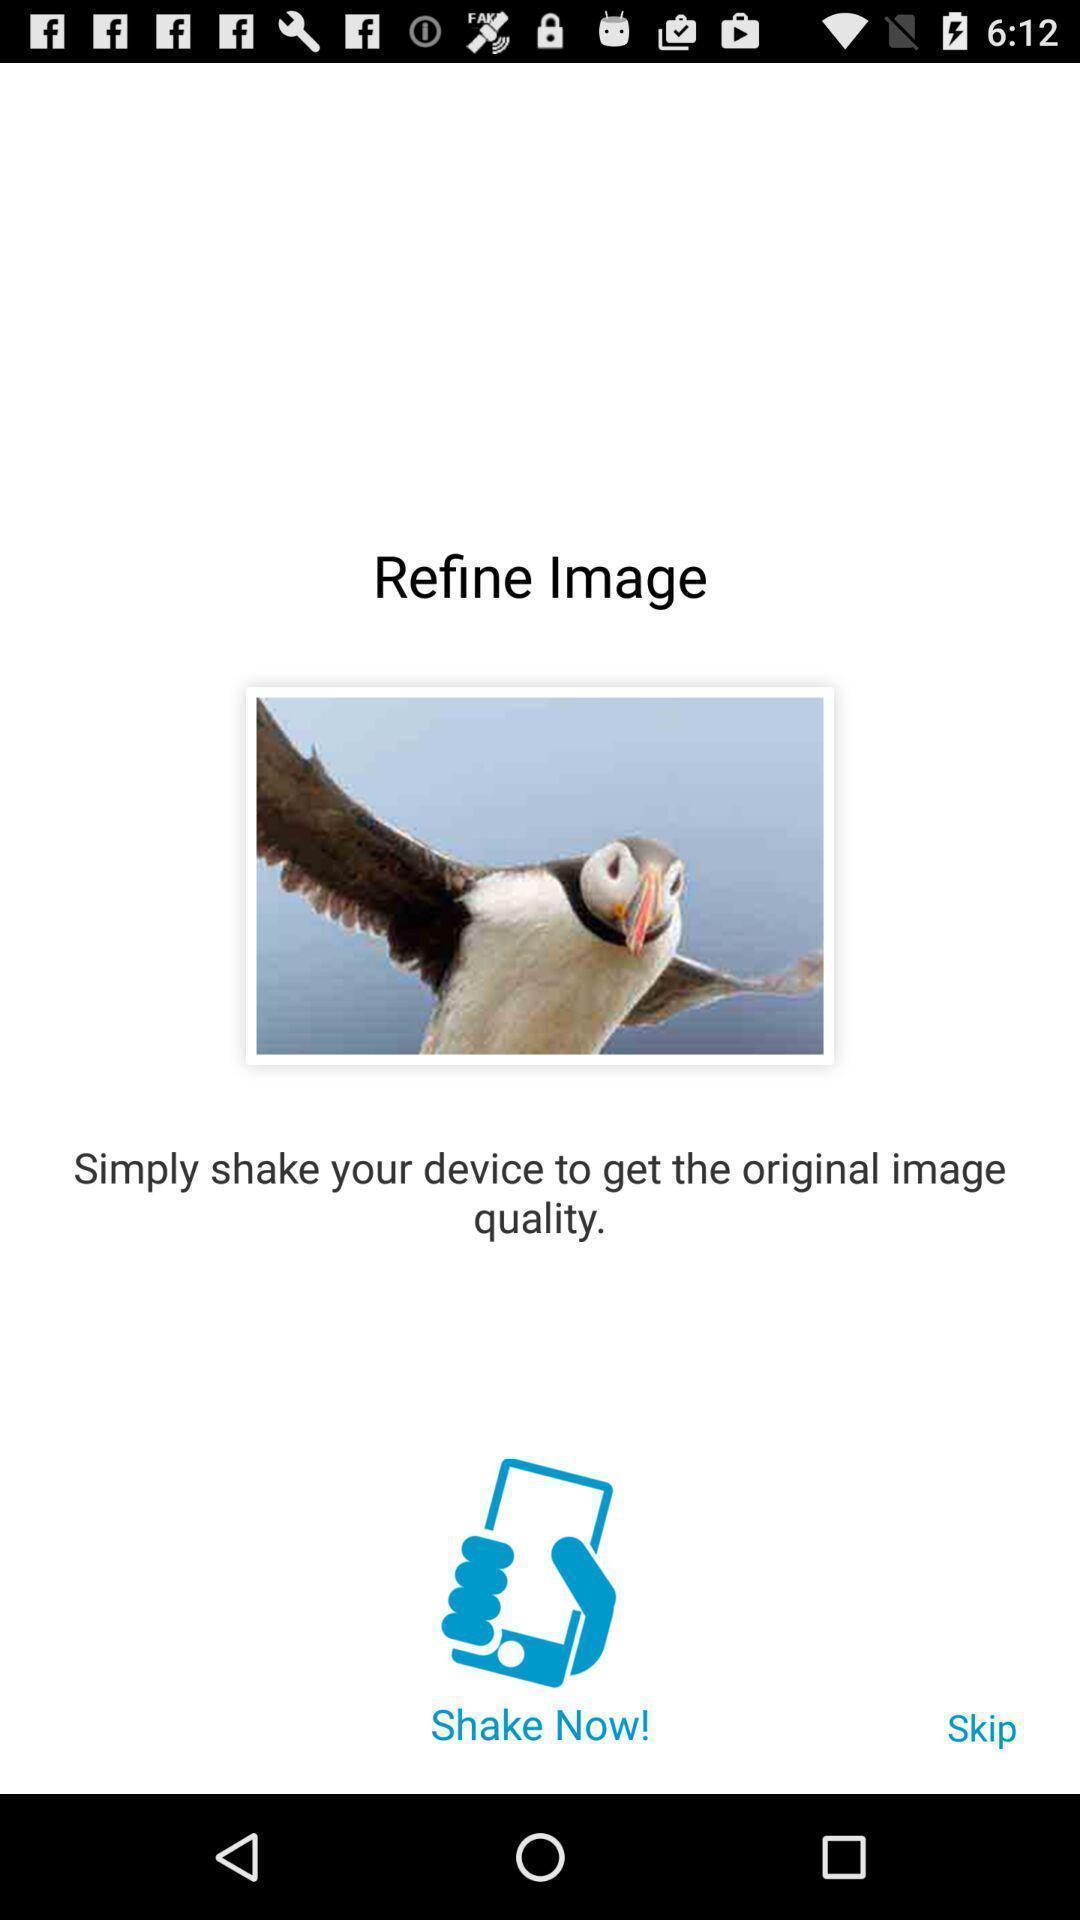Tell me what you see in this picture. Page displays an image in app. 